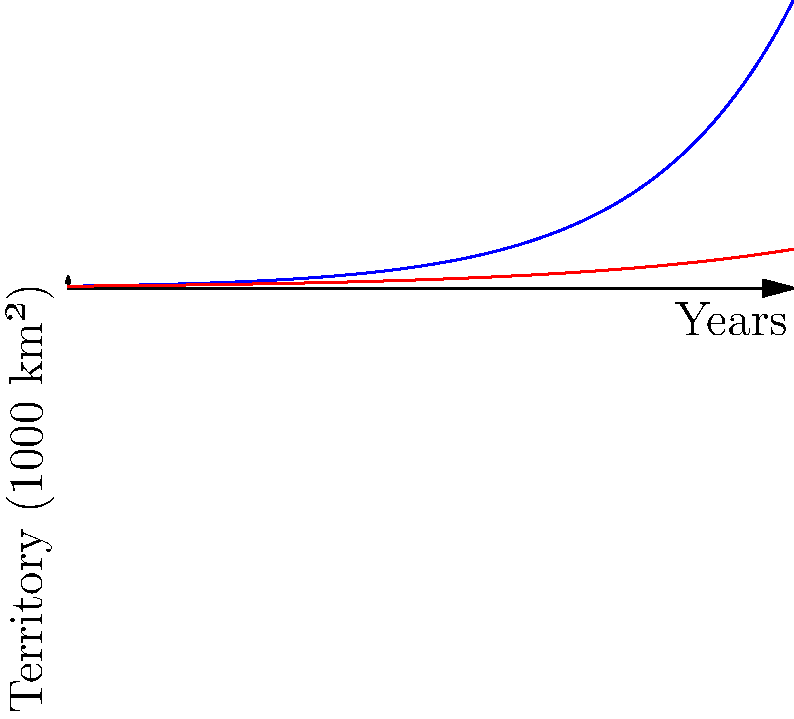The graph shows the territorial expansion of two medieval Eurasian empires over a century, modeled by exponential functions. Empire A's growth is represented by $A(t) = 100e^{0.05t}$, and Empire B's by $B(t) = 100e^{0.03t}$, where $t$ is time in years and the result is in thousands of square kilometers. After how many years does Empire A's territory become twice that of Empire B? To solve this problem, we need to follow these steps:

1) We want to find $t$ where $A(t) = 2B(t)$

2) Substitute the given functions:
   $100e^{0.05t} = 2(100e^{0.03t})$

3) Simplify:
   $100e^{0.05t} = 200e^{0.03t}$
   $e^{0.05t} = 2e^{0.03t}$

4) Take natural log of both sides:
   $\ln(e^{0.05t}) = \ln(2e^{0.03t})$
   $0.05t = \ln(2) + 0.03t$

5) Solve for $t$:
   $0.02t = \ln(2)$
   $t = \frac{\ln(2)}{0.02}$

6) Calculate the result:
   $t \approx 34.66$ years

Therefore, after approximately 34.66 years, Empire A's territory becomes twice that of Empire B.
Answer: 34.66 years 